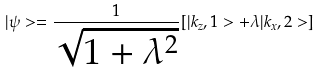<formula> <loc_0><loc_0><loc_500><loc_500>| \psi > = \frac { 1 } { \sqrt { 1 + \lambda ^ { 2 } } } [ | k _ { z } , 1 > + \lambda | k _ { x } , 2 > ]</formula> 